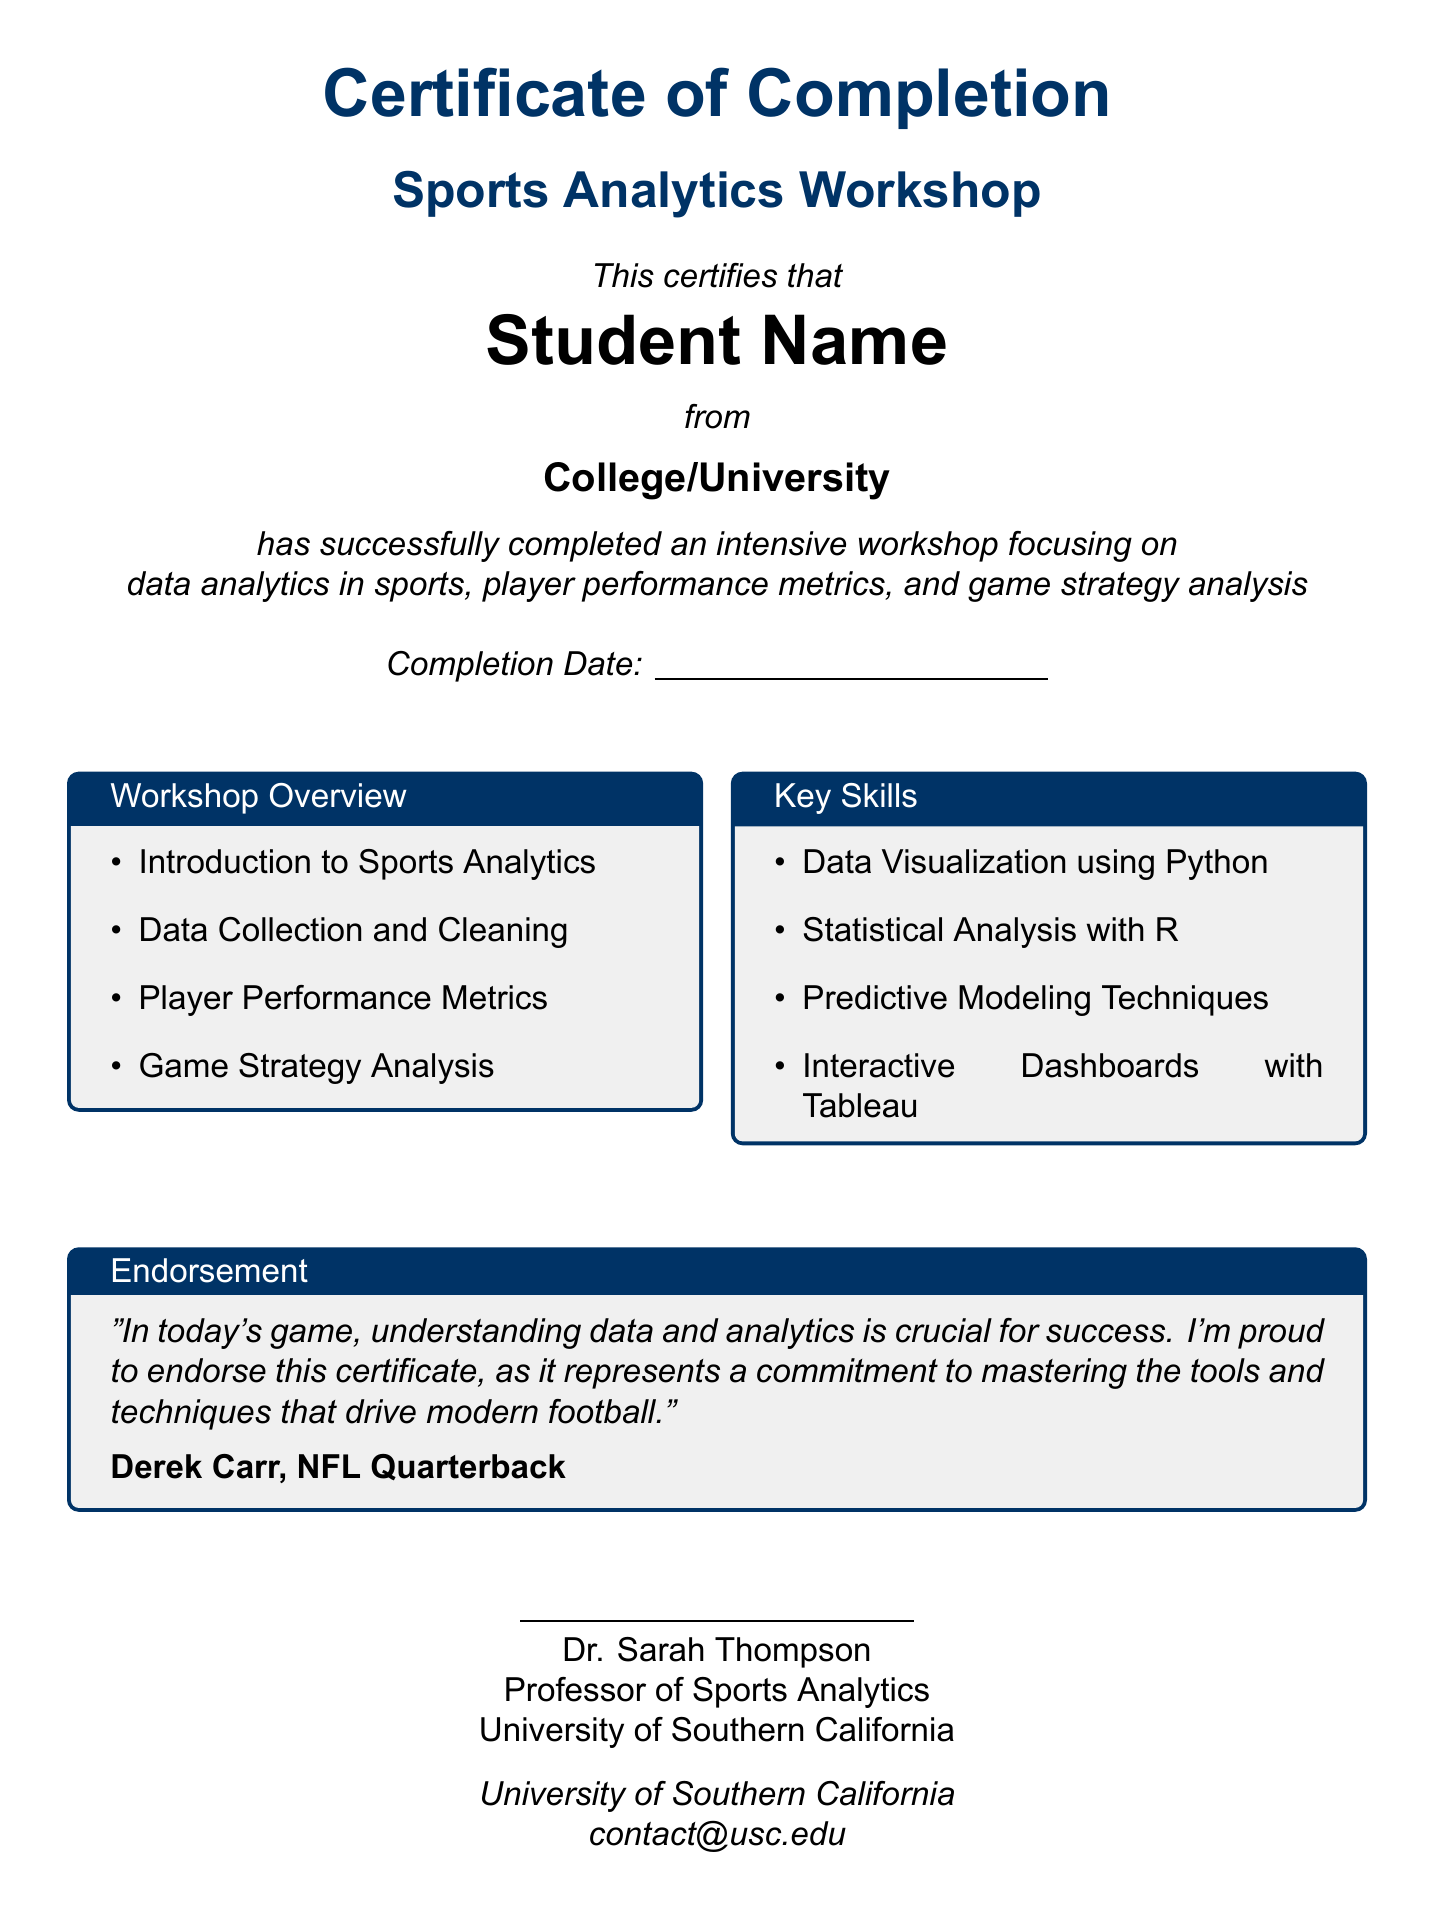What is the title of the certificate? The title of the certificate is prominently displayed at the top of the document as "Certificate of Completion."
Answer: Certificate of Completion Who is the certificate awarded to? The name of the recipient appears in bold after the phrase "This certifies that."
Answer: Student Name What is the name of the workshop? The name of the workshop is mentioned directly below the title of the certificate.
Answer: Sports Analytics Workshop What is the completion date mentioned in the certificate? The document includes a blank line for the completion date which specifies the date of completion.
Answer: \underline{\hspace{5cm}} Who is the endorsing person for the certificate? The endorsement section identifies the individual who supports the certificate.
Answer: Derek Carr What are two key skills learned in the workshop? The document lists various skills learned, among which the following are included: Data Visualization using Python and Statistical Analysis with R.
Answer: Data Visualization using Python, Statistical Analysis with R What institution is associated with the professor mentioned? The certificate identifies the university where the professor teaches at the bottom section of the document.
Answer: University of Southern California What color is used for the title text in the certificate? The color of the title text is specified in the document, indicating a specific RGB value.
Answer: darkblue How many topics are included in the workshop overview? The workshop overview section lists four distinct topics covered in the workshop.
Answer: 4 